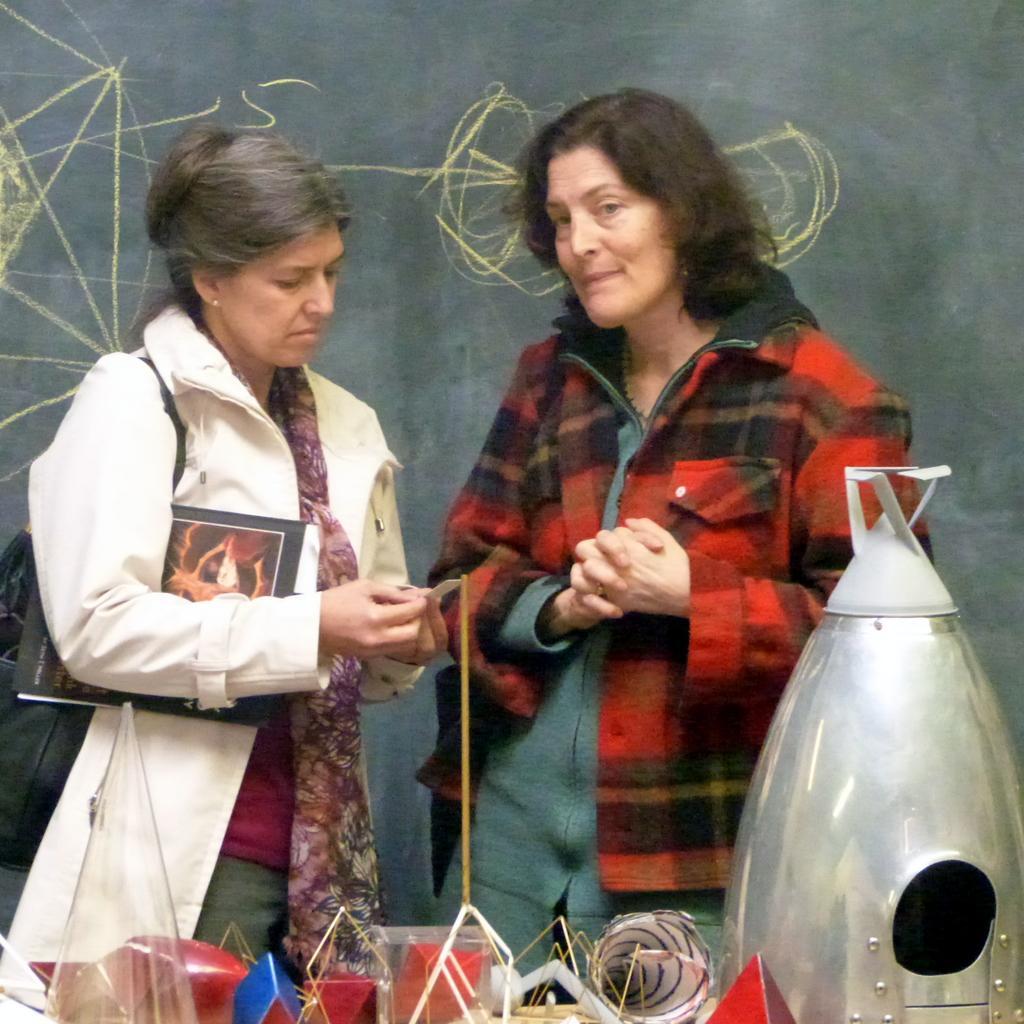In one or two sentences, can you explain what this image depicts? At the bottom of the image there are many things made with paper. On the right side of the mage there is an object which looks like a rocket. Behind them there are two ladies standing. On the left side of the image there is a lady holding a book. Behind them on the chalkboard there are some lines. 